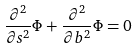Convert formula to latex. <formula><loc_0><loc_0><loc_500><loc_500>\frac { { \partial } ^ { 2 } } { { \partial } s ^ { 2 } } { \Phi } + \frac { { \partial } ^ { 2 } } { { \partial } b ^ { 2 } } { \Phi } = 0</formula> 